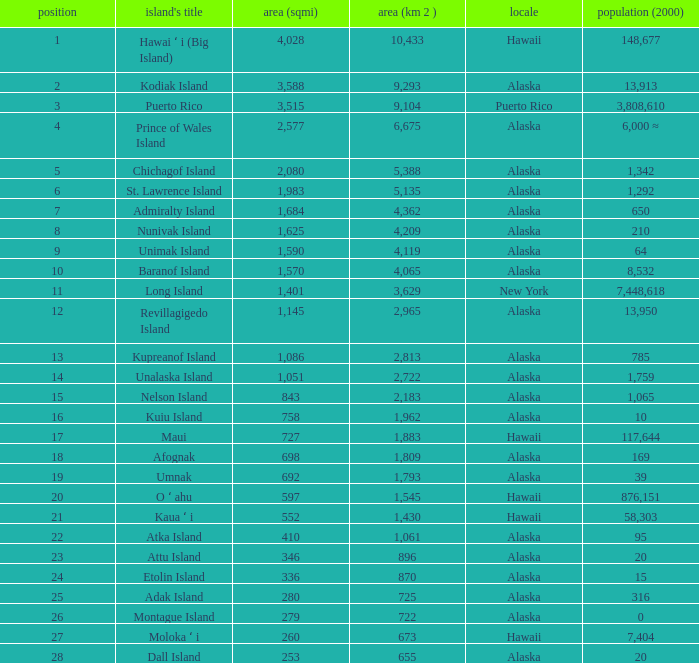What is the highest rank for Nelson Island with area more than 2,183? None. 